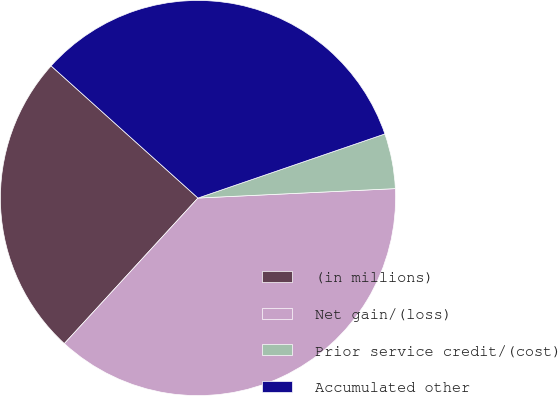Convert chart to OTSL. <chart><loc_0><loc_0><loc_500><loc_500><pie_chart><fcel>(in millions)<fcel>Net gain/(loss)<fcel>Prior service credit/(cost)<fcel>Accumulated other<nl><fcel>24.84%<fcel>37.58%<fcel>4.5%<fcel>33.08%<nl></chart> 